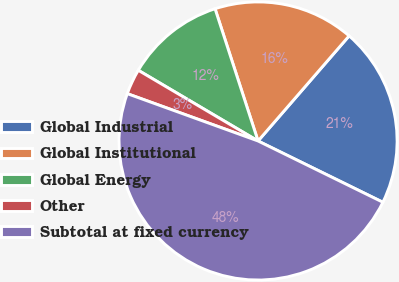<chart> <loc_0><loc_0><loc_500><loc_500><pie_chart><fcel>Global Industrial<fcel>Global Institutional<fcel>Global Energy<fcel>Other<fcel>Subtotal at fixed currency<nl><fcel>20.9%<fcel>16.37%<fcel>11.51%<fcel>2.96%<fcel>48.27%<nl></chart> 